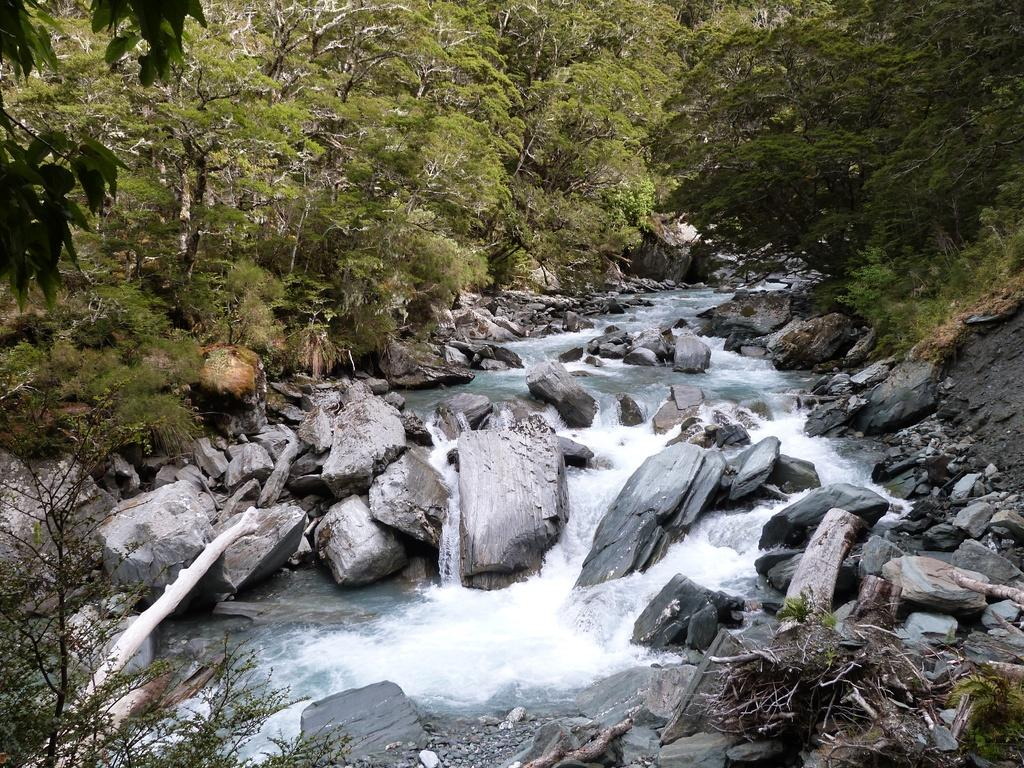What type of natural elements can be seen in the image? There are rocks, water, plants, and trees visible in the image. Can you describe the water in the image? The water is visible in the image, but its specific characteristics are not mentioned. What type of vegetation is present in the image? There are plants and trees in the image. What type of sofa can be seen in the image? There is no sofa present in the image; it features natural elements such as rocks, water, plants, and trees. What color are the teeth of the plants in the image? Plants do not have teeth, so this question cannot be answered based on the information provided. 